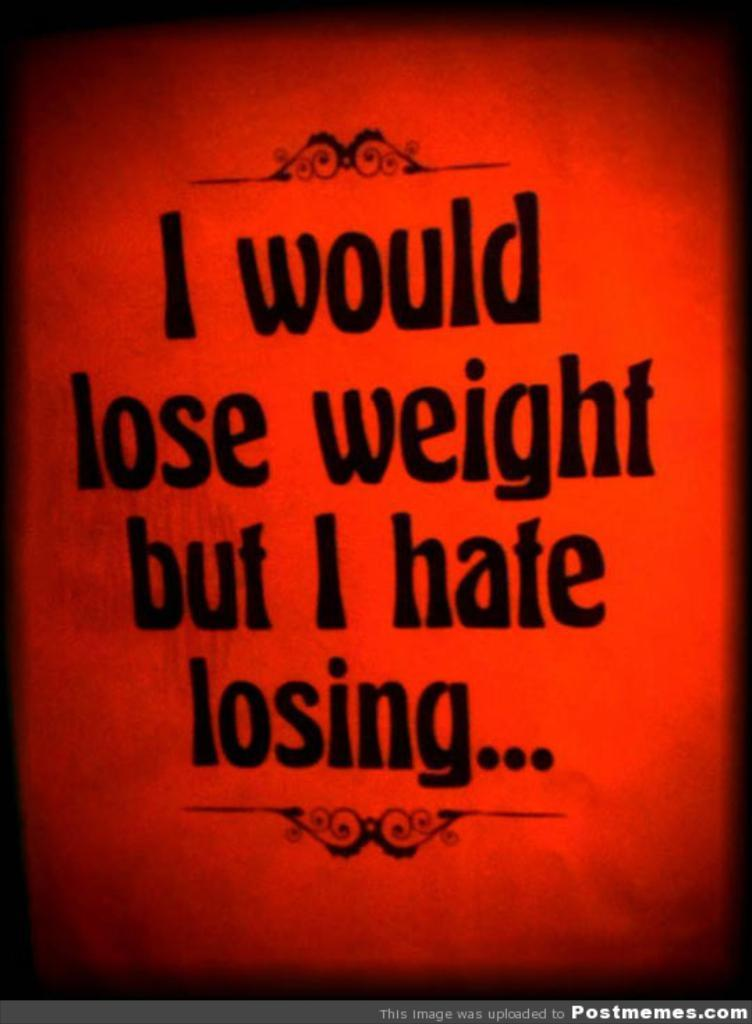<image>
Describe the image concisely. A sign says I would lose weight but I hate losing. 